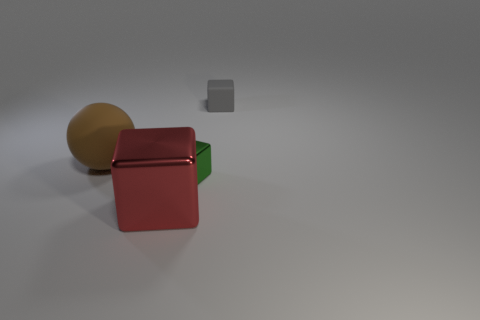Is there a red thing of the same shape as the brown matte thing?
Ensure brevity in your answer.  No. There is a rubber object that is to the left of the small thing that is behind the sphere; what shape is it?
Offer a very short reply. Sphere. How many red things are made of the same material as the brown thing?
Your response must be concise. 0. What color is the small thing that is the same material as the red block?
Offer a terse response. Green. How big is the matte thing to the left of the metallic thing behind the metal thing on the left side of the tiny green metallic block?
Give a very brief answer. Large. Are there fewer big red things than gray shiny cylinders?
Give a very brief answer. No. There is another small rubber object that is the same shape as the small green object; what is its color?
Keep it short and to the point. Gray. Are there any large brown balls that are behind the big thing behind the big metallic object that is left of the tiny green object?
Give a very brief answer. No. Do the large red thing and the gray thing have the same shape?
Make the answer very short. Yes. Is the number of small rubber blocks in front of the gray thing less than the number of large brown shiny things?
Keep it short and to the point. No. 